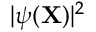<formula> <loc_0><loc_0><loc_500><loc_500>| \psi ( { X } ) | ^ { 2 }</formula> 